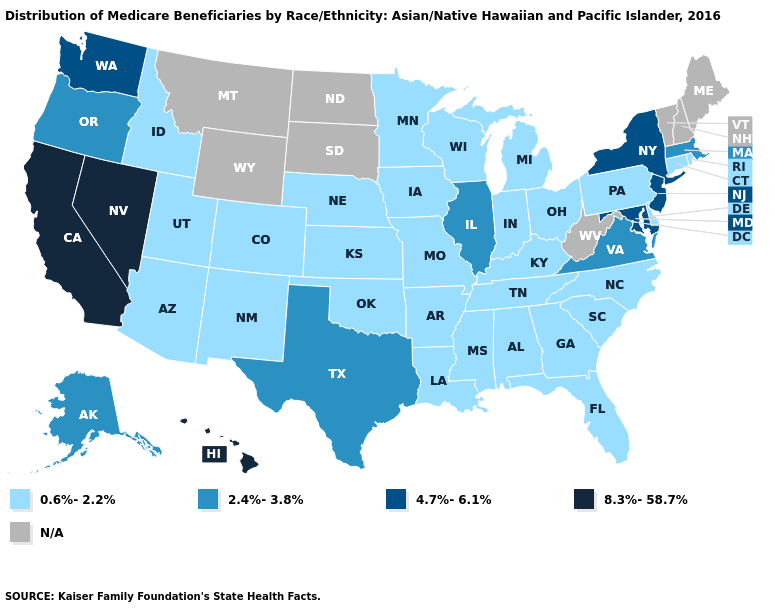Which states have the highest value in the USA?
Quick response, please. California, Hawaii, Nevada. Which states have the highest value in the USA?
Answer briefly. California, Hawaii, Nevada. Name the states that have a value in the range 8.3%-58.7%?
Concise answer only. California, Hawaii, Nevada. What is the value of Maine?
Give a very brief answer. N/A. What is the lowest value in states that border Nevada?
Give a very brief answer. 0.6%-2.2%. Name the states that have a value in the range 8.3%-58.7%?
Answer briefly. California, Hawaii, Nevada. Does Nevada have the highest value in the West?
Write a very short answer. Yes. Name the states that have a value in the range 2.4%-3.8%?
Be succinct. Alaska, Illinois, Massachusetts, Oregon, Texas, Virginia. Name the states that have a value in the range 8.3%-58.7%?
Concise answer only. California, Hawaii, Nevada. Name the states that have a value in the range 8.3%-58.7%?
Be succinct. California, Hawaii, Nevada. Name the states that have a value in the range 8.3%-58.7%?
Give a very brief answer. California, Hawaii, Nevada. Name the states that have a value in the range 4.7%-6.1%?
Give a very brief answer. Maryland, New Jersey, New York, Washington. 